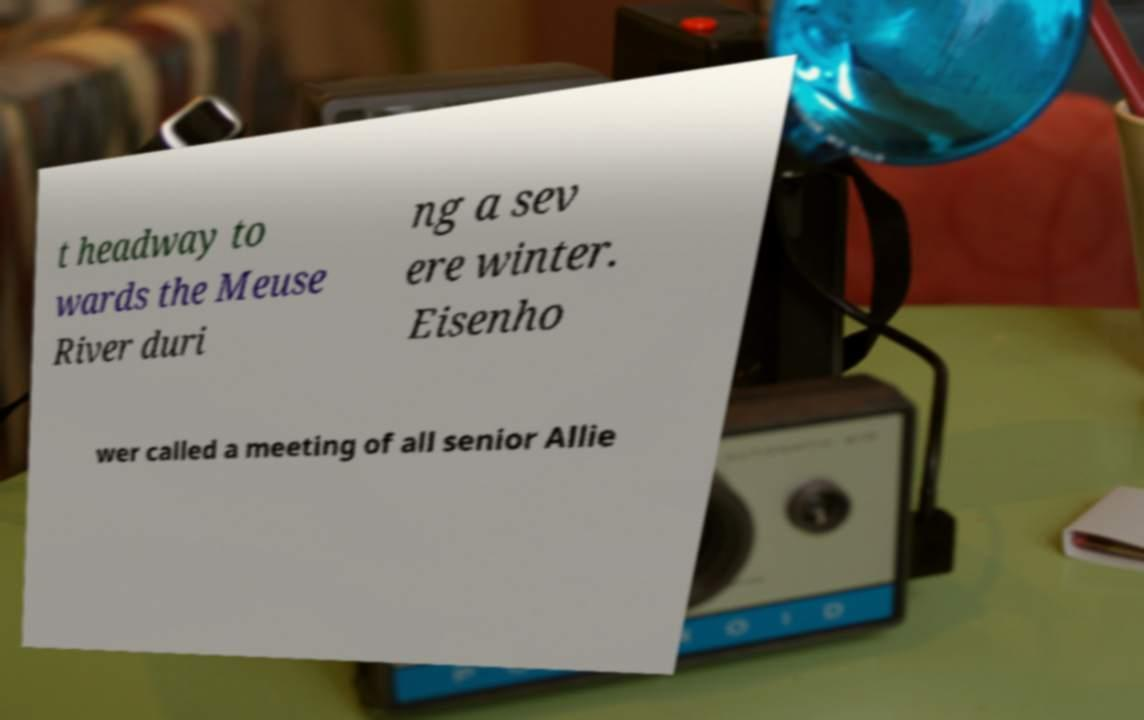I need the written content from this picture converted into text. Can you do that? t headway to wards the Meuse River duri ng a sev ere winter. Eisenho wer called a meeting of all senior Allie 